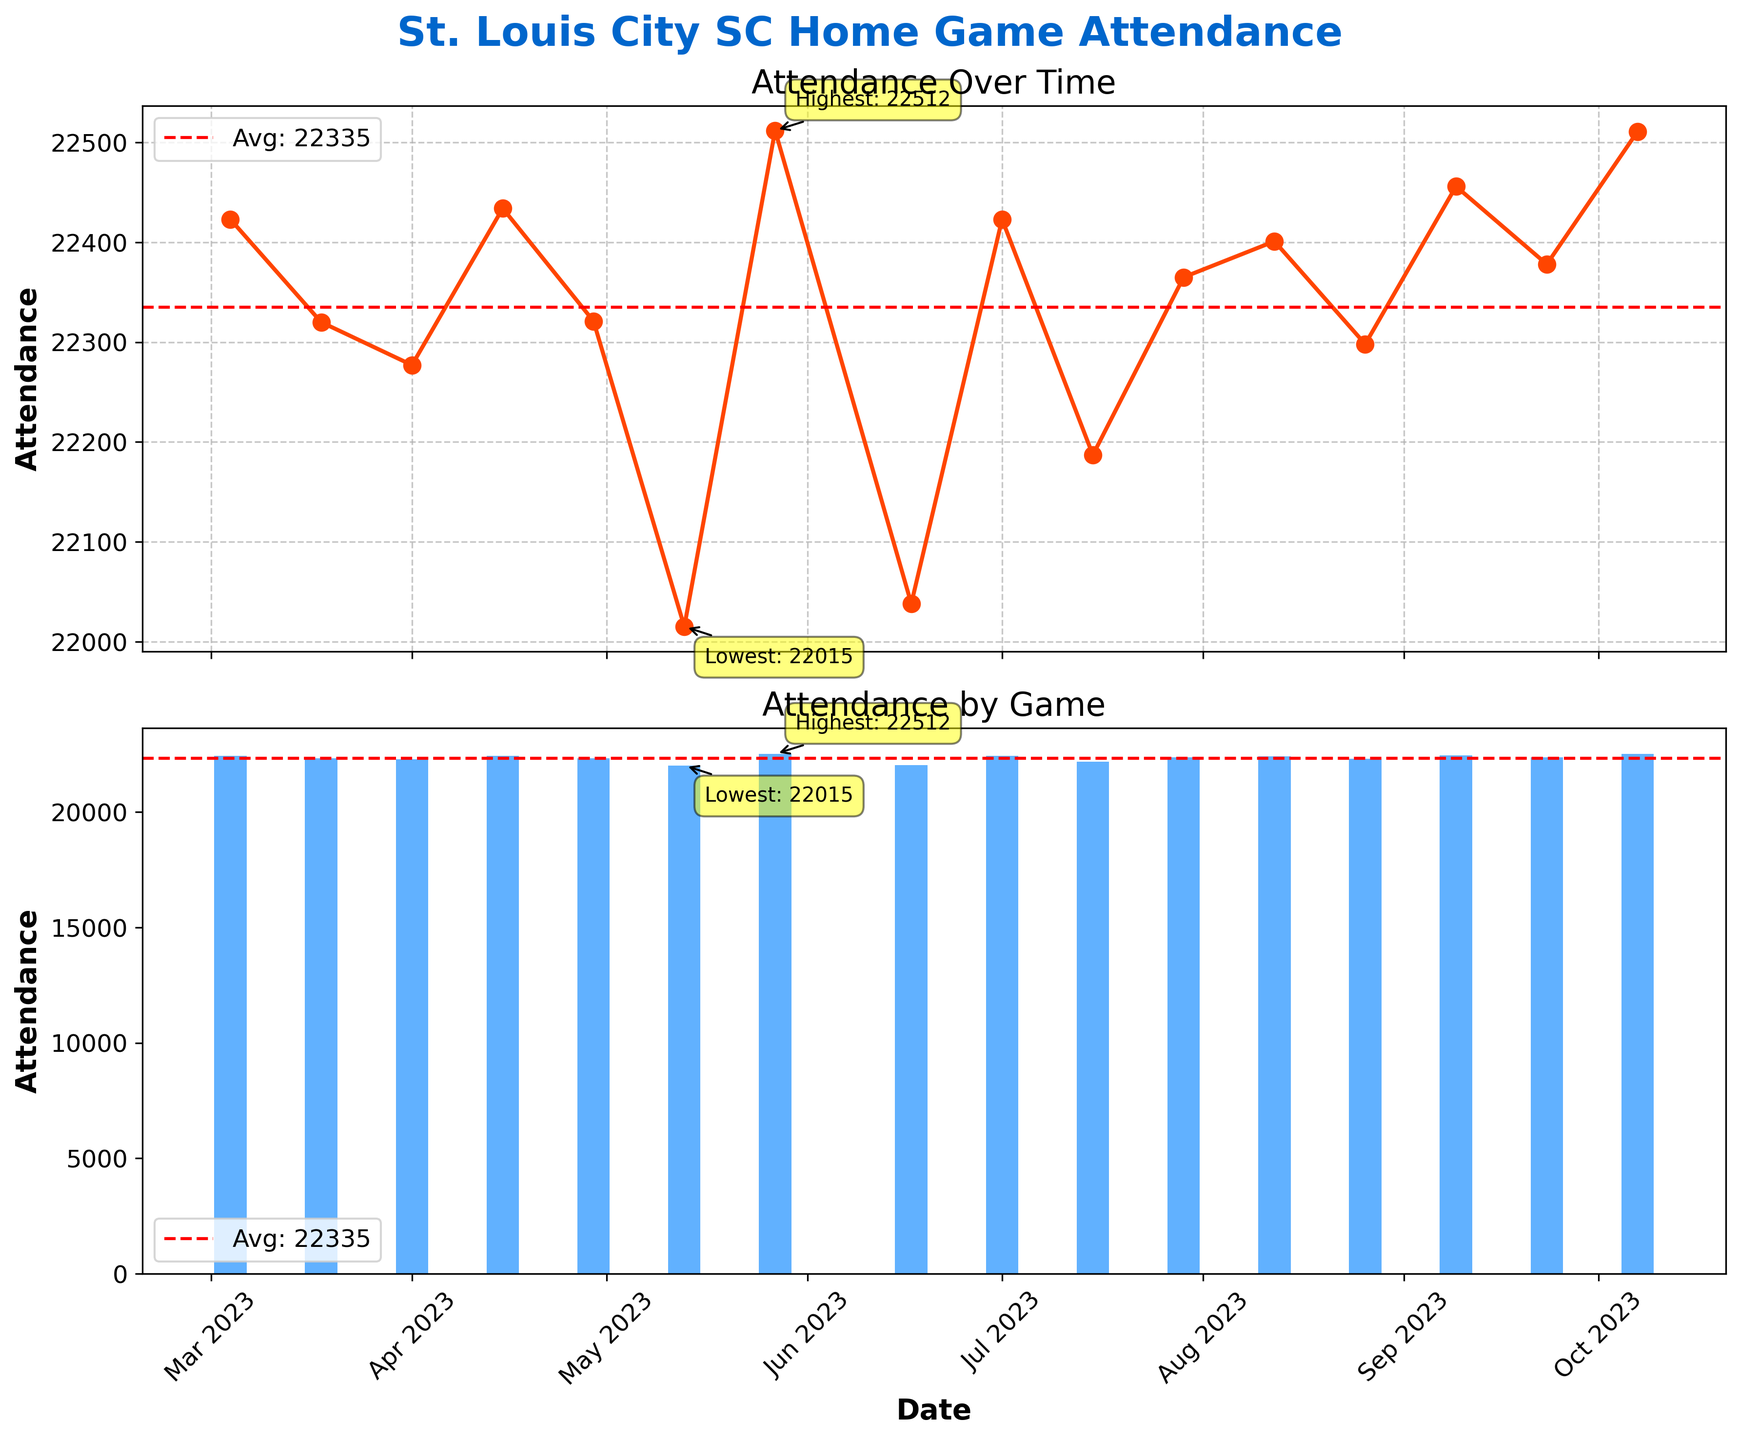What is the title of the entire figure? The title is located at the top of the figure in a large, bold font that stands out.
Answer: St. Louis City SC Home Game Attendance What colors are used in the line and bar plots? The line plot uses a red color for the line and dots, and the bar plot uses a blue color for the bars. These colors are distinct and easily recognizable.
Answer: Red and Blue Which game had the highest attendance? The highest attendance is annotated with a yellow box and an arrow pointing to the specific data point in both the line and bar plots.
Answer: 2023-05-27 What is the average attendance throughout the season? The average attendance is indicated by a horizontal dashed red line labeled "Avg" in both subplots.
Answer: 22,459 What is the attendance trend over time in the line plot? By observing the line plot with the markers, one can see the general pattern of the data points over the time series.
Answer: Relatively stable with slight fluctuations What is the difference in attendance between the highest and lowest attended games? Identify the highest and lowest attendance values annotated in the plots, then calculate the difference: 22,512 - 22,015 = 497.
Answer: 497 Which month had the most games with attendance above the average? Check the number of bars that are higher than the average line in each month in the bar plot.
Answer: July and September (Both have 2 games above average) How many games had attendance lower than 22,300? Look at the bar plot to count how many bars are below the 22,300 mark.
Answer: 4 games Is there a particular month where the attendance consistently falls below the average attendance? Examine the bar plot for months where all bars are below the average attendance line.
Answer: May (Most bars below average) Is the highest attendance value greater than the average attendance? Compare the highest attendance value, 22,512, to the average attendance, 22,459. Since 22,512 is greater, the answer is yes.
Answer: Yes 